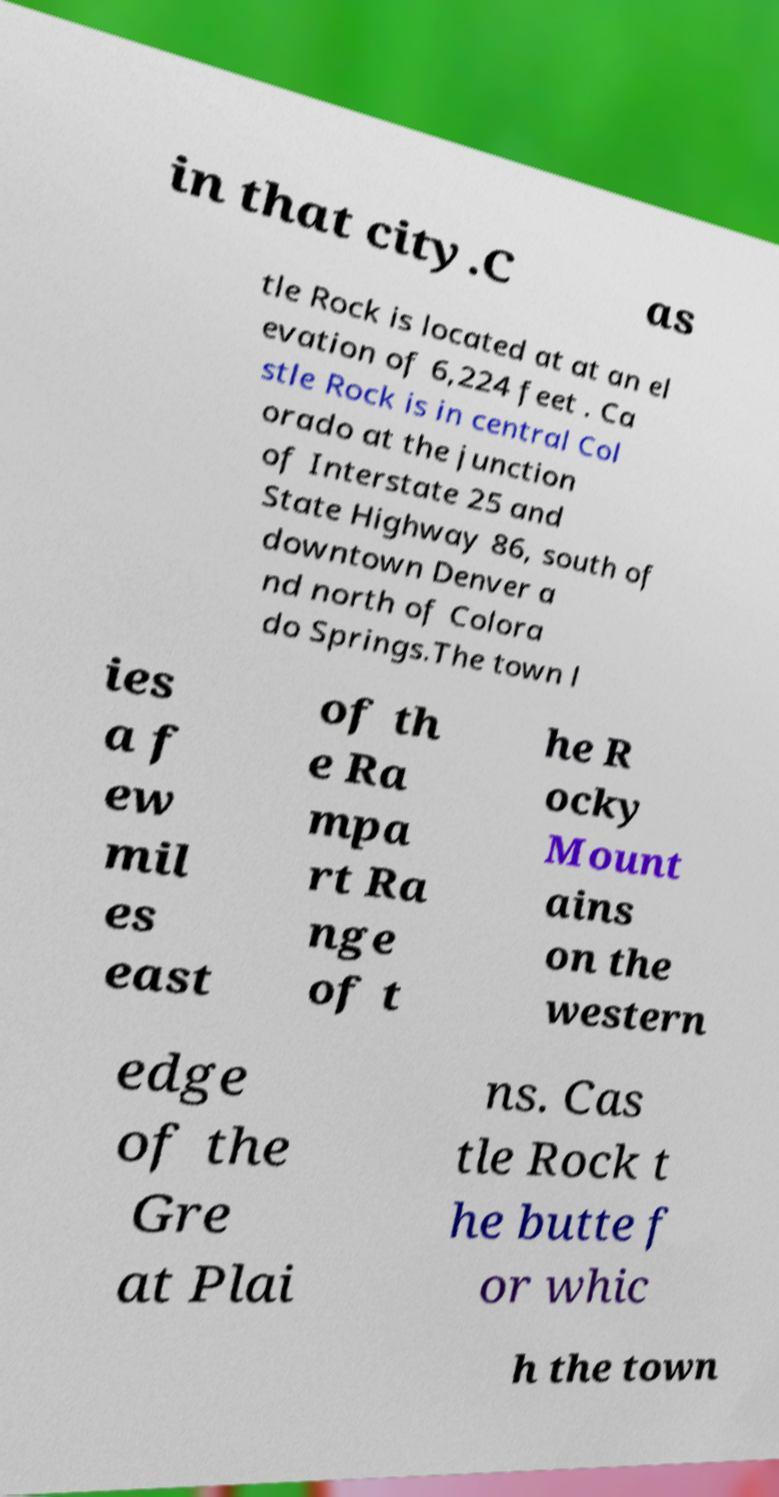There's text embedded in this image that I need extracted. Can you transcribe it verbatim? in that city.C as tle Rock is located at at an el evation of 6,224 feet . Ca stle Rock is in central Col orado at the junction of Interstate 25 and State Highway 86, south of downtown Denver a nd north of Colora do Springs.The town l ies a f ew mil es east of th e Ra mpa rt Ra nge of t he R ocky Mount ains on the western edge of the Gre at Plai ns. Cas tle Rock t he butte f or whic h the town 